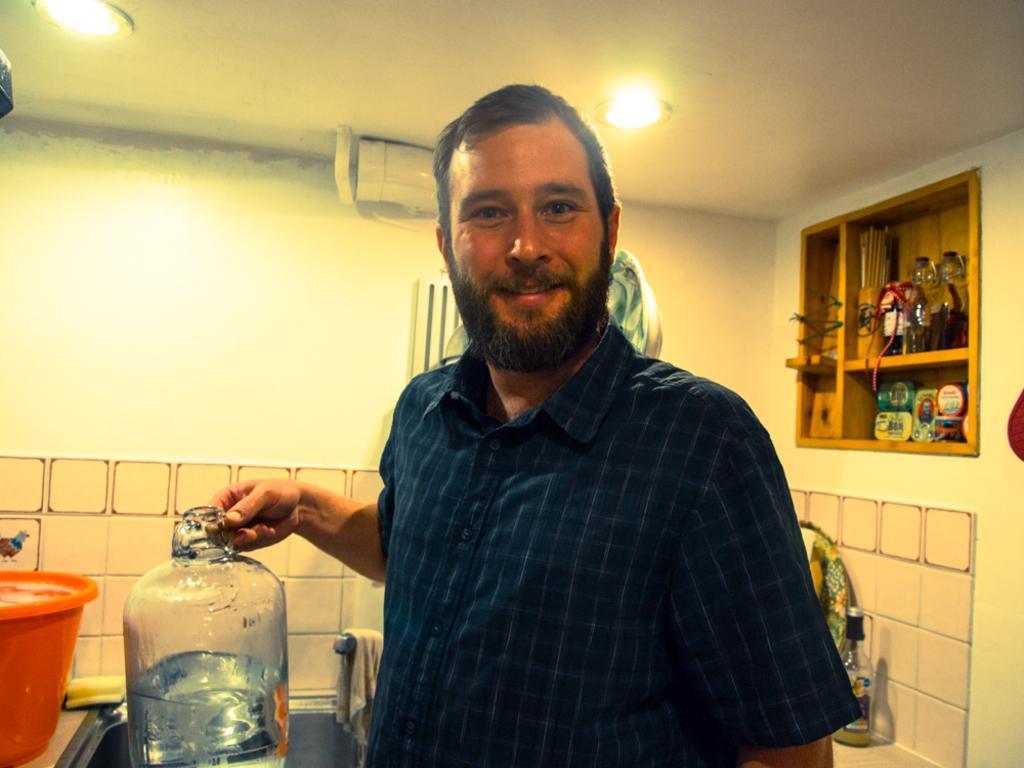Describe this image in one or two sentences. In this image there is a person, container, water can, rack, lights, bottle, sink, cloth, tap and objects. In that rock there are things. 